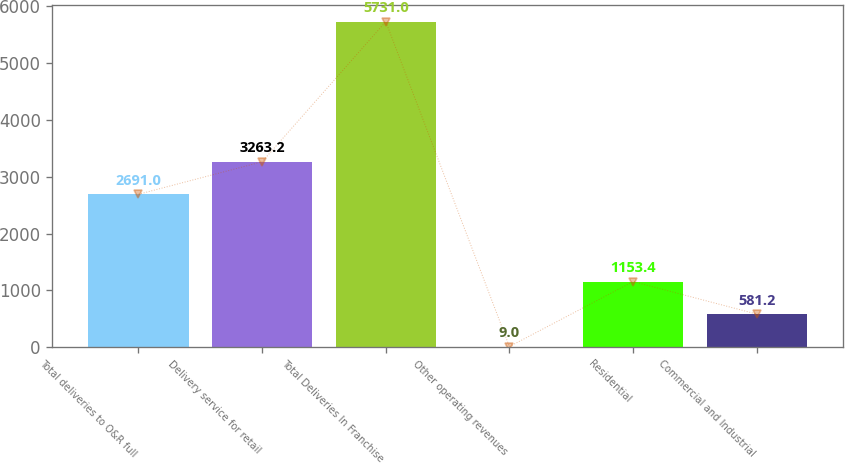Convert chart. <chart><loc_0><loc_0><loc_500><loc_500><bar_chart><fcel>Total deliveries to O&R full<fcel>Delivery service for retail<fcel>Total Deliveries In Franchise<fcel>Other operating revenues<fcel>Residential<fcel>Commercial and Industrial<nl><fcel>2691<fcel>3263.2<fcel>5731<fcel>9<fcel>1153.4<fcel>581.2<nl></chart> 